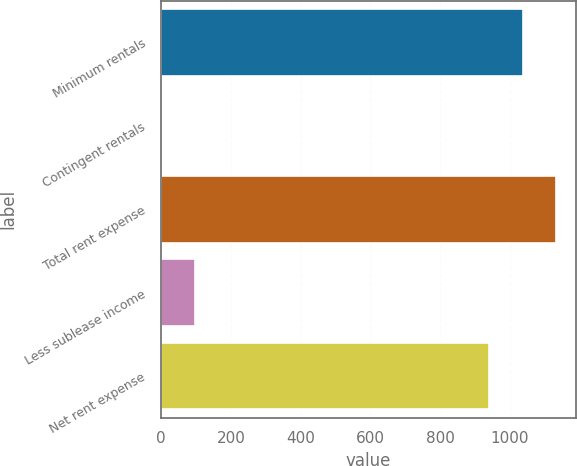<chart> <loc_0><loc_0><loc_500><loc_500><bar_chart><fcel>Minimum rentals<fcel>Contingent rentals<fcel>Total rent expense<fcel>Less sublease income<fcel>Net rent expense<nl><fcel>1036.2<fcel>1<fcel>1132.4<fcel>97.2<fcel>940<nl></chart> 